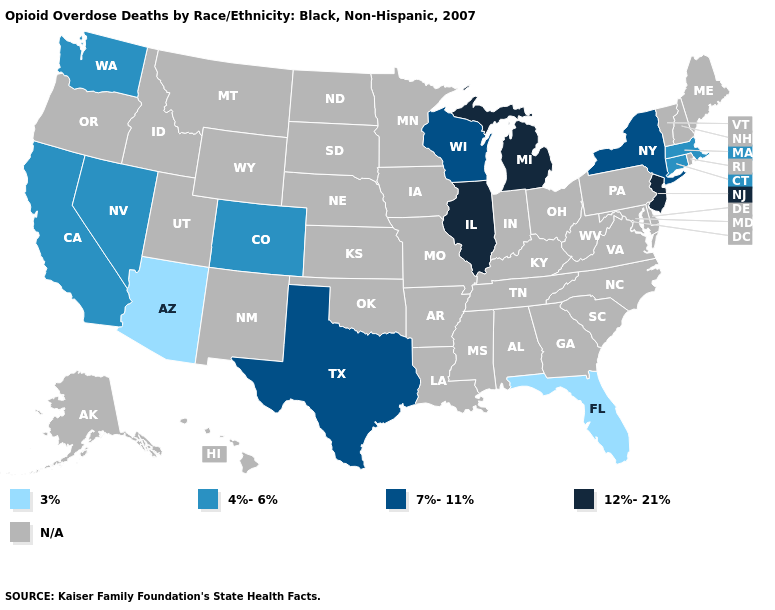Which states have the lowest value in the South?
Be succinct. Florida. Does Wisconsin have the lowest value in the MidWest?
Concise answer only. Yes. What is the value of Colorado?
Answer briefly. 4%-6%. Name the states that have a value in the range N/A?
Answer briefly. Alabama, Alaska, Arkansas, Delaware, Georgia, Hawaii, Idaho, Indiana, Iowa, Kansas, Kentucky, Louisiana, Maine, Maryland, Minnesota, Mississippi, Missouri, Montana, Nebraska, New Hampshire, New Mexico, North Carolina, North Dakota, Ohio, Oklahoma, Oregon, Pennsylvania, Rhode Island, South Carolina, South Dakota, Tennessee, Utah, Vermont, Virginia, West Virginia, Wyoming. What is the lowest value in the USA?
Answer briefly. 3%. What is the lowest value in the MidWest?
Write a very short answer. 7%-11%. What is the value of Colorado?
Keep it brief. 4%-6%. What is the value of Wisconsin?
Be succinct. 7%-11%. What is the highest value in the South ?
Be succinct. 7%-11%. What is the value of New York?
Quick response, please. 7%-11%. What is the lowest value in the USA?
Short answer required. 3%. What is the value of Indiana?
Be succinct. N/A. What is the value of Nebraska?
Keep it brief. N/A. 